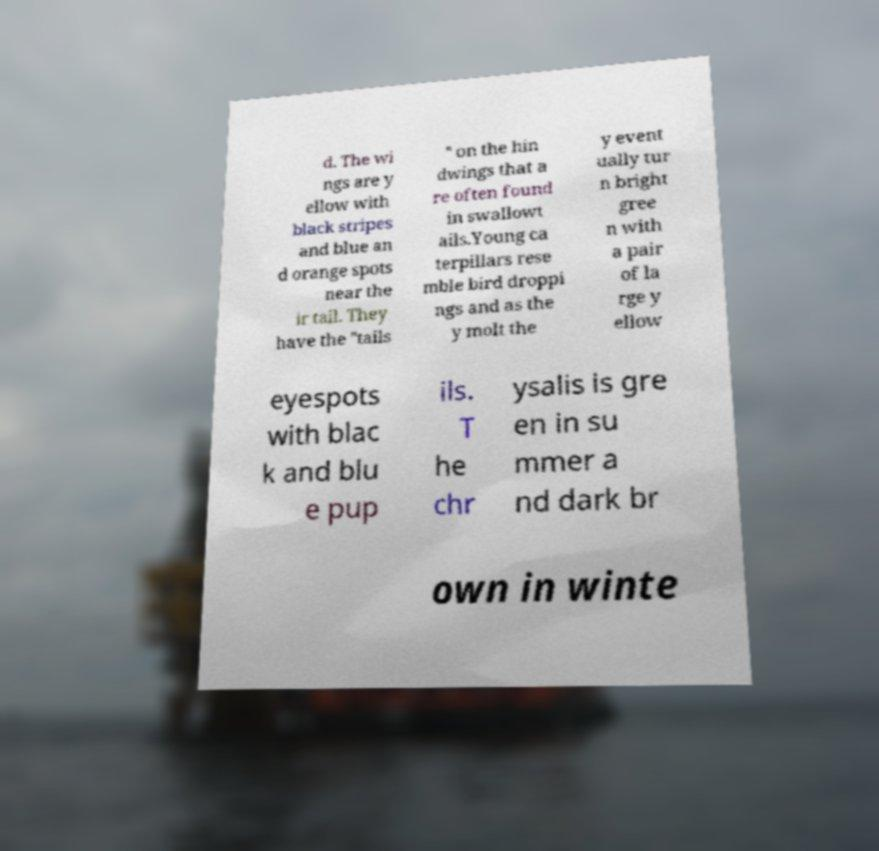Can you read and provide the text displayed in the image?This photo seems to have some interesting text. Can you extract and type it out for me? d. The wi ngs are y ellow with black stripes and blue an d orange spots near the ir tail. They have the "tails " on the hin dwings that a re often found in swallowt ails.Young ca terpillars rese mble bird droppi ngs and as the y molt the y event ually tur n bright gree n with a pair of la rge y ellow eyespots with blac k and blu e pup ils. T he chr ysalis is gre en in su mmer a nd dark br own in winte 